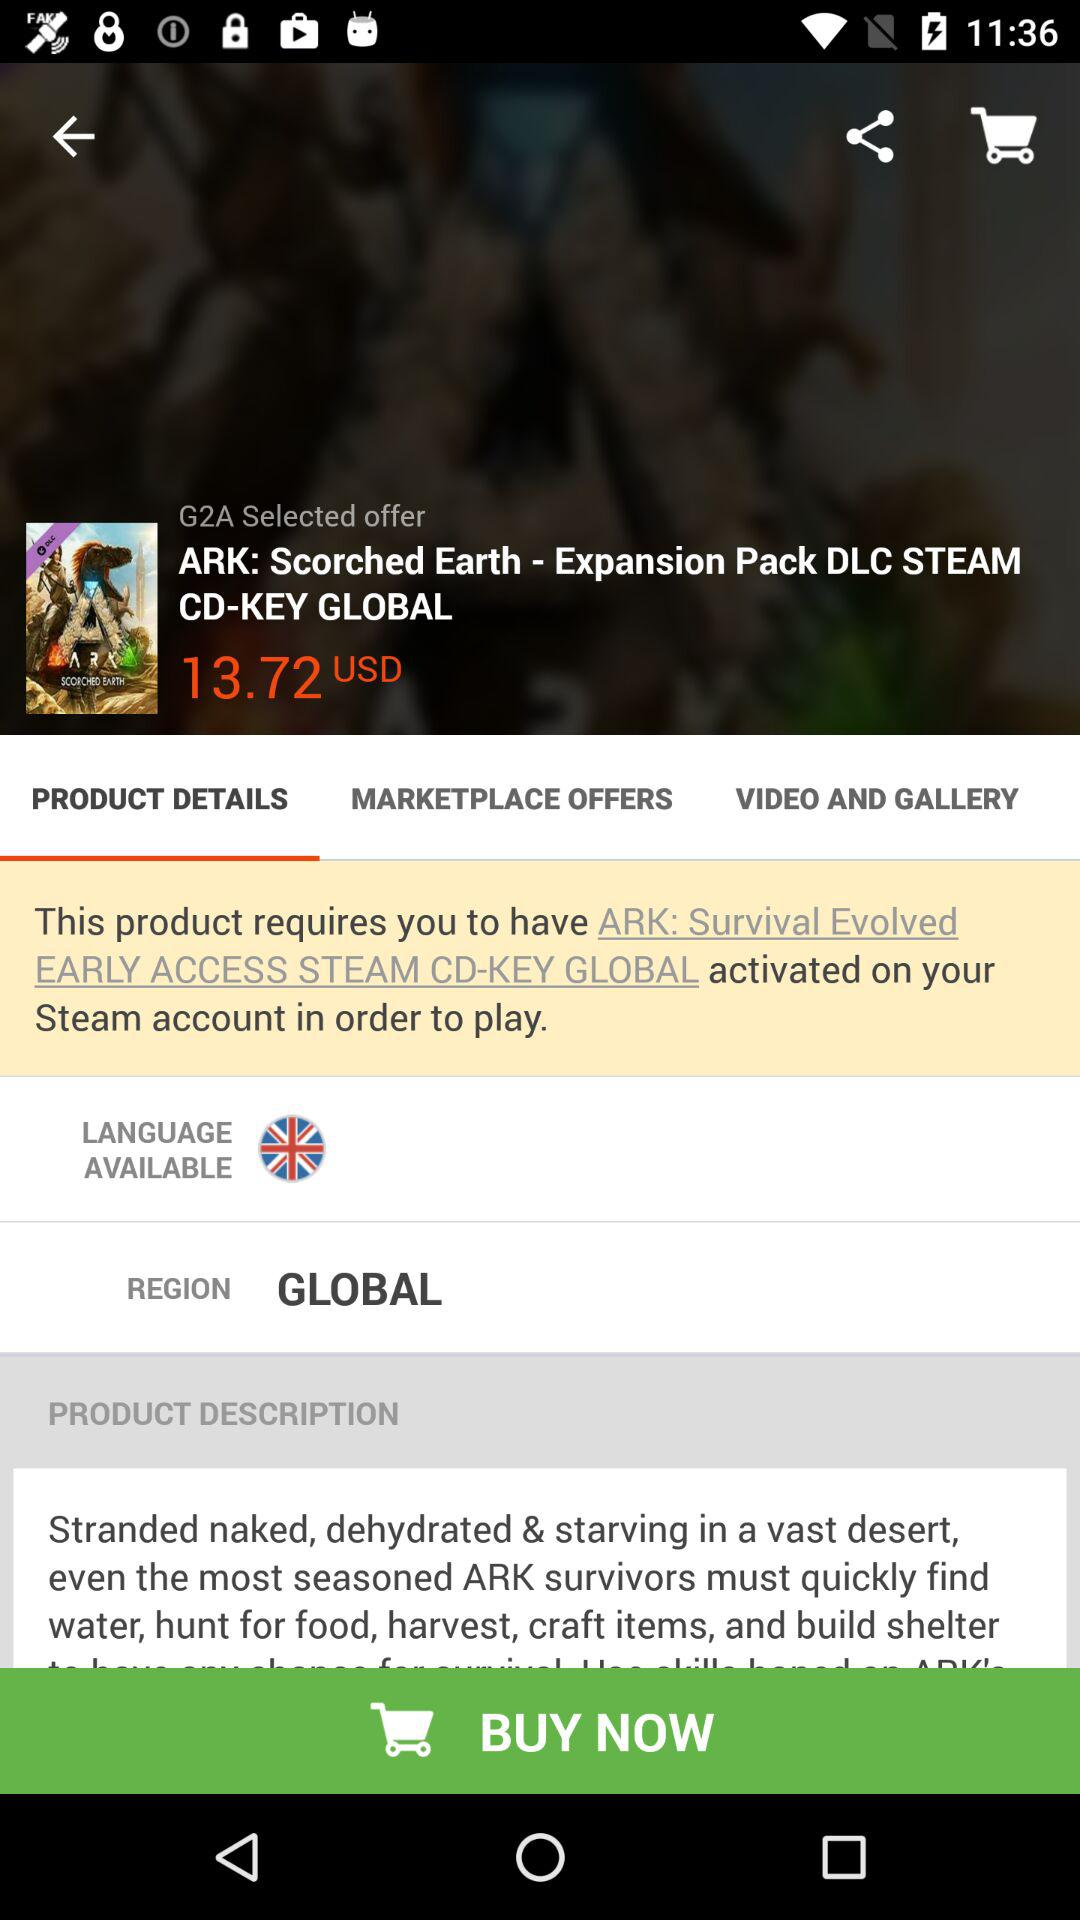Which option is selected? The selected option is "PRODUCT DETAILS". 